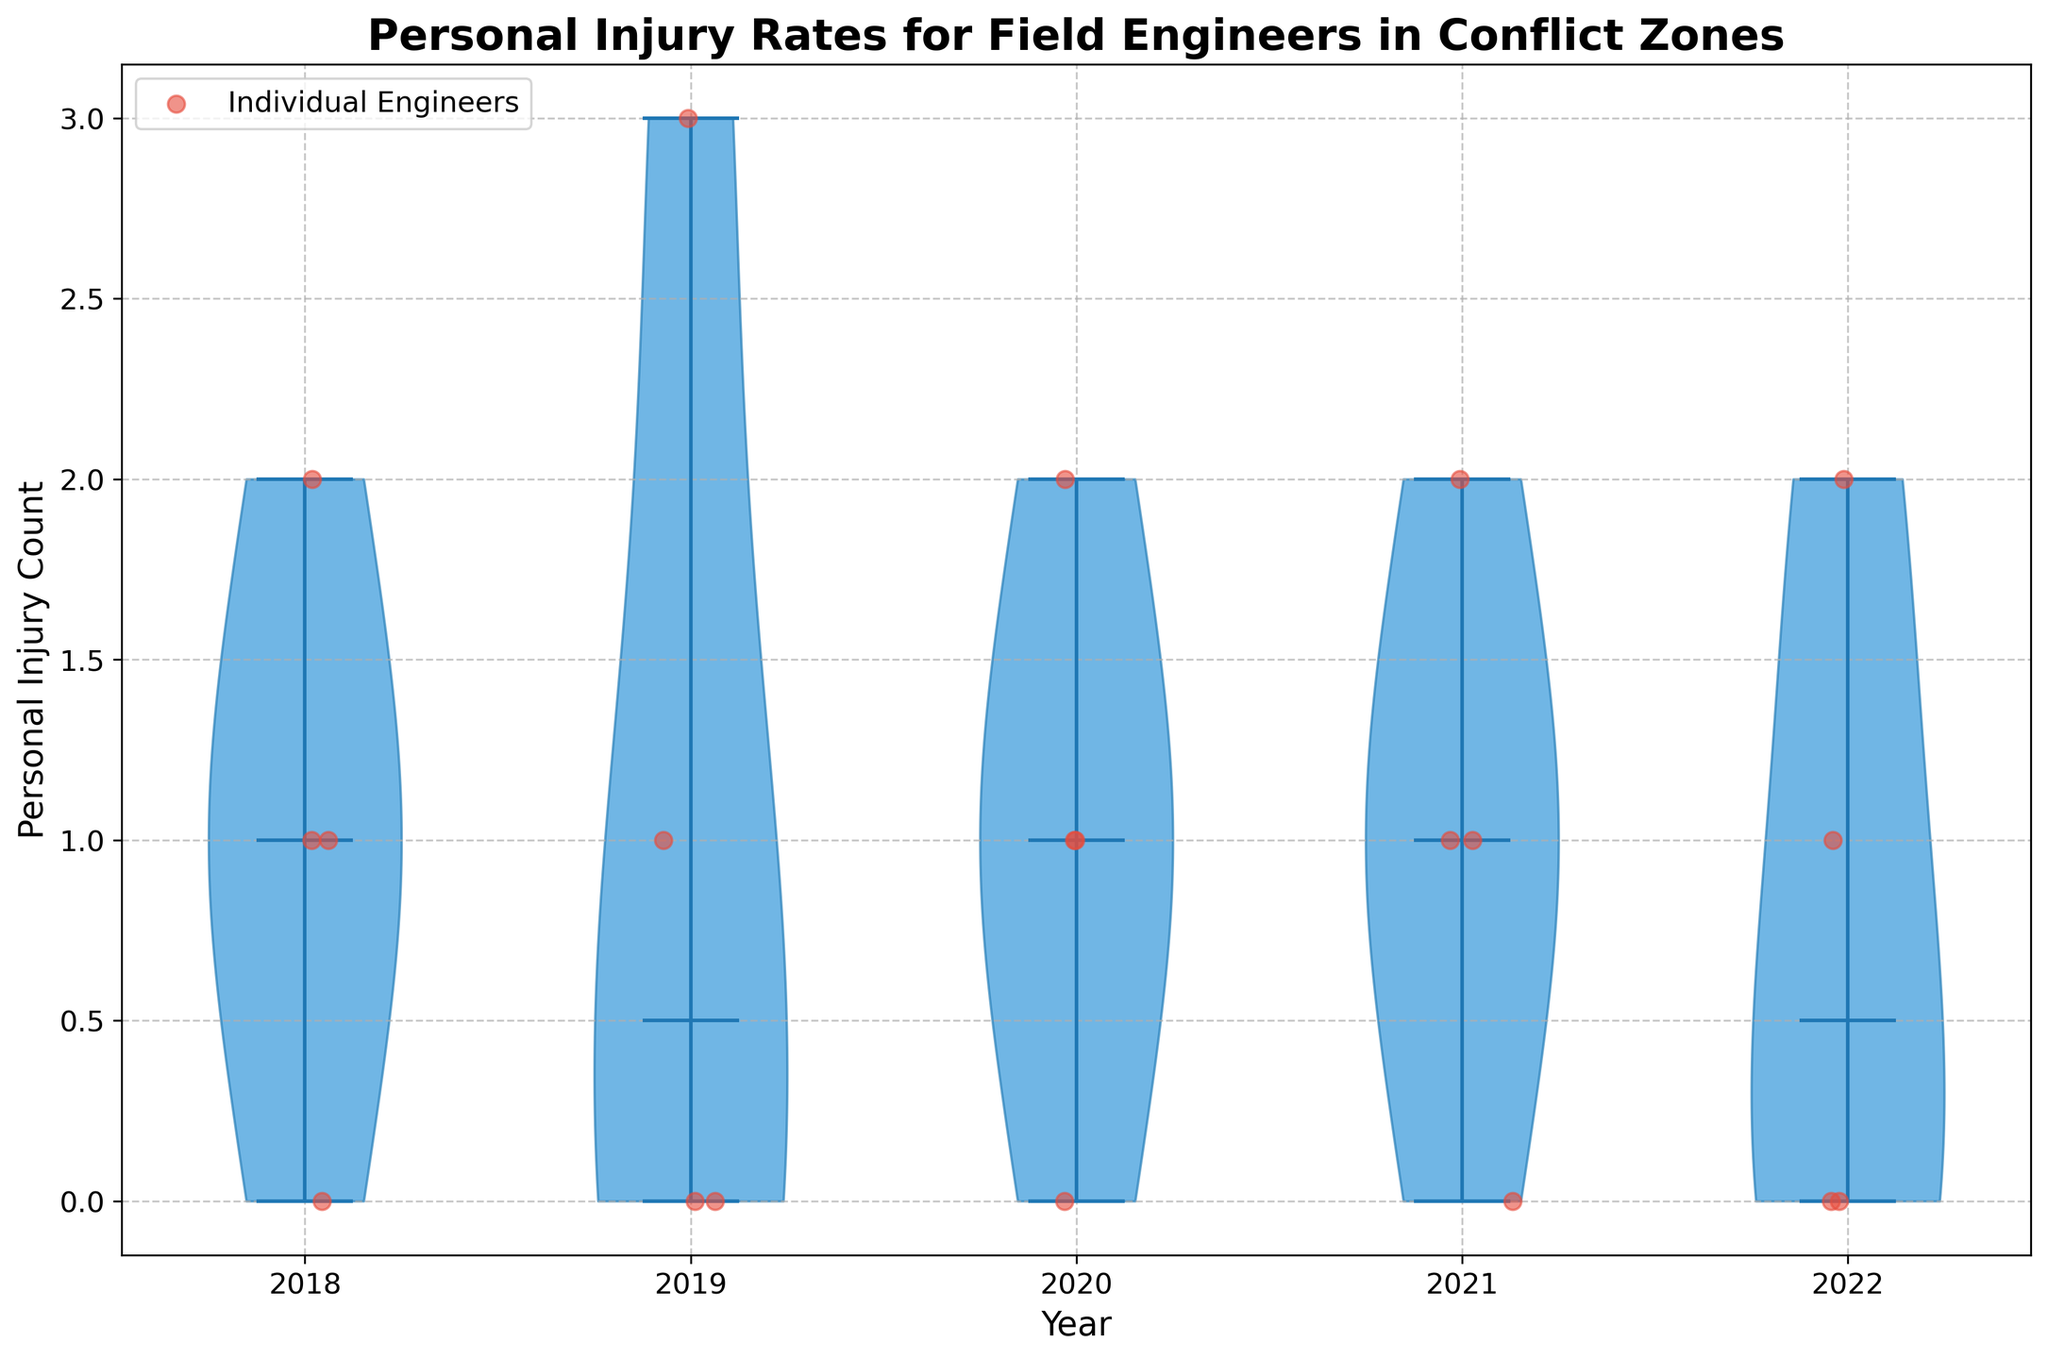What is the title of the figure? The title is displayed at the top of the figure and reads "Personal Injury Rates for Field Engineers in Conflict Zones".
Answer: Personal Injury Rates for Field Engineers in Conflict Zones How does the median injury rate for engineers change from 2018 to 2022? The medians are indicated by the central lines in each violin. By comparing these lines, we can see that the median values start at around 1 in 2018 and 1 in 2022, indicating no change.
Answer: No change What is the highest personal injury count for any engineer, and in which year does it occur? We can see the highest points recorded in the jittered plots. The highest point is 3 and it occurs in 2019.
Answer: 3 in 2019 Which year has the widest spread in personal injury rates? By observing the width of the violins, 2019 shows the largest spread as the violin shape is the widest, indicating a higher variance in the data.
Answer: 2019 How many engineers had no personal injuries in 2020? The jittered points placed at a value of 0 within the 2020 section represent engineers with no injuries. Counting these points, we find there is 1 engineer with no personal injuries in 2020.
Answer: 1 Which year shows the most engineers with a personal injury count of 1? Refer to the jittered points. The highest concentration around the point 1 on the Y-axis is in 2018 with 2 engineers.
Answer: 2018 In which year is the median injury rate equal to 2? The median is marked by a line inside the violins. For 2021, the median line is at the 2 count mark.
Answer: 2021 What can you tell about the general trend in personal injury rates over the years? Observing the medians and spread of the violins, there is no clear increasing or decreasing trend overall as median values fluctuate without a consistent pattern.
Answer: No clear trend Are there any individual years where all engineers had at least one personal injury? We can check the jittered points for each year. In 2018, there are personal injuries of 1 or more, thus no year shows all engineers with at least one injury.
Answer: No 